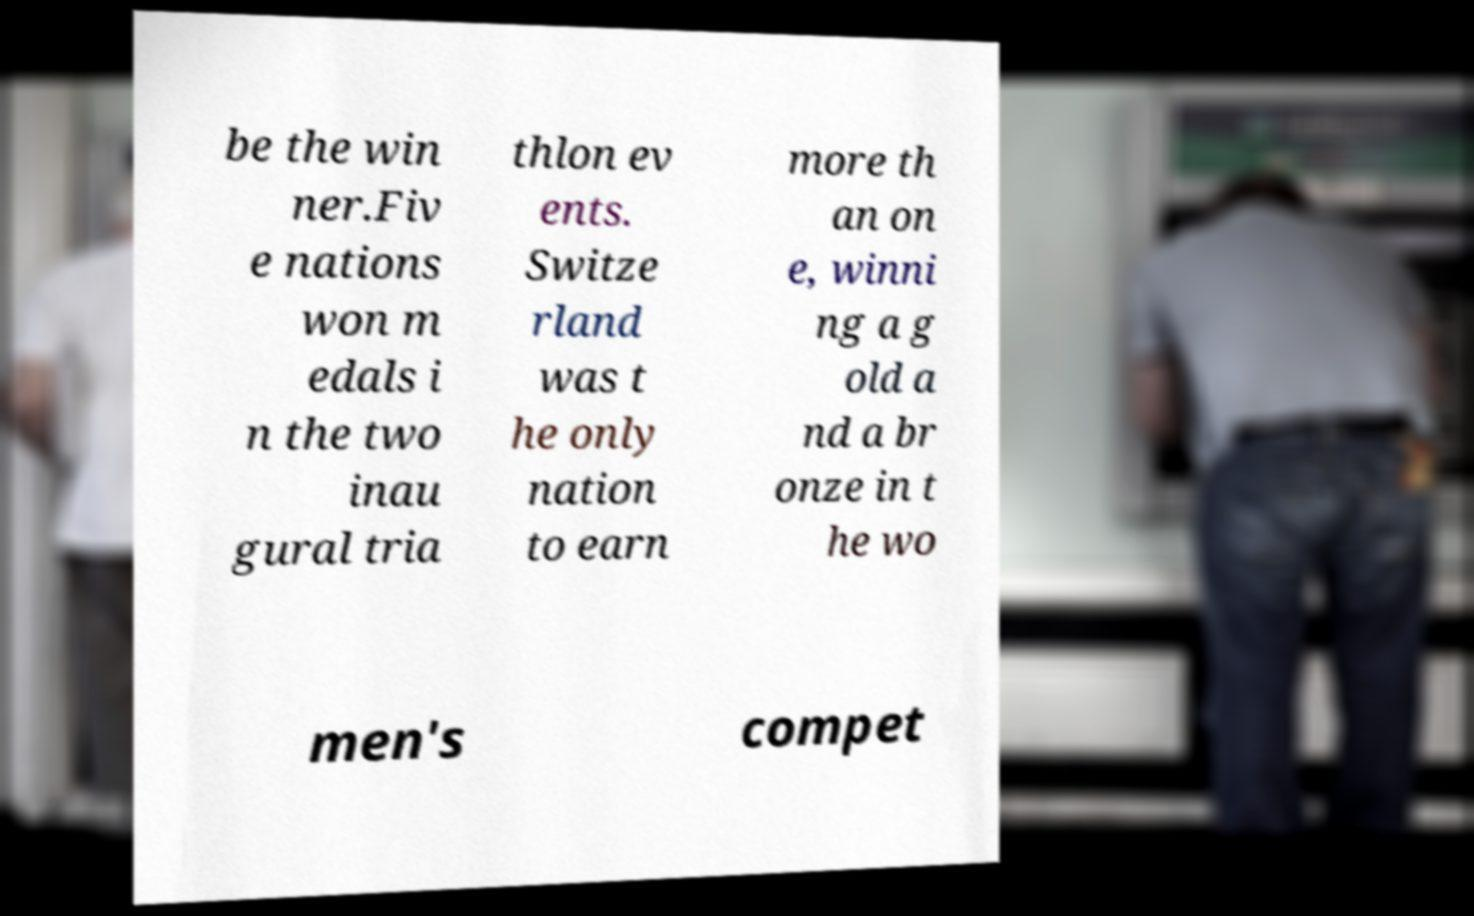Can you accurately transcribe the text from the provided image for me? be the win ner.Fiv e nations won m edals i n the two inau gural tria thlon ev ents. Switze rland was t he only nation to earn more th an on e, winni ng a g old a nd a br onze in t he wo men's compet 